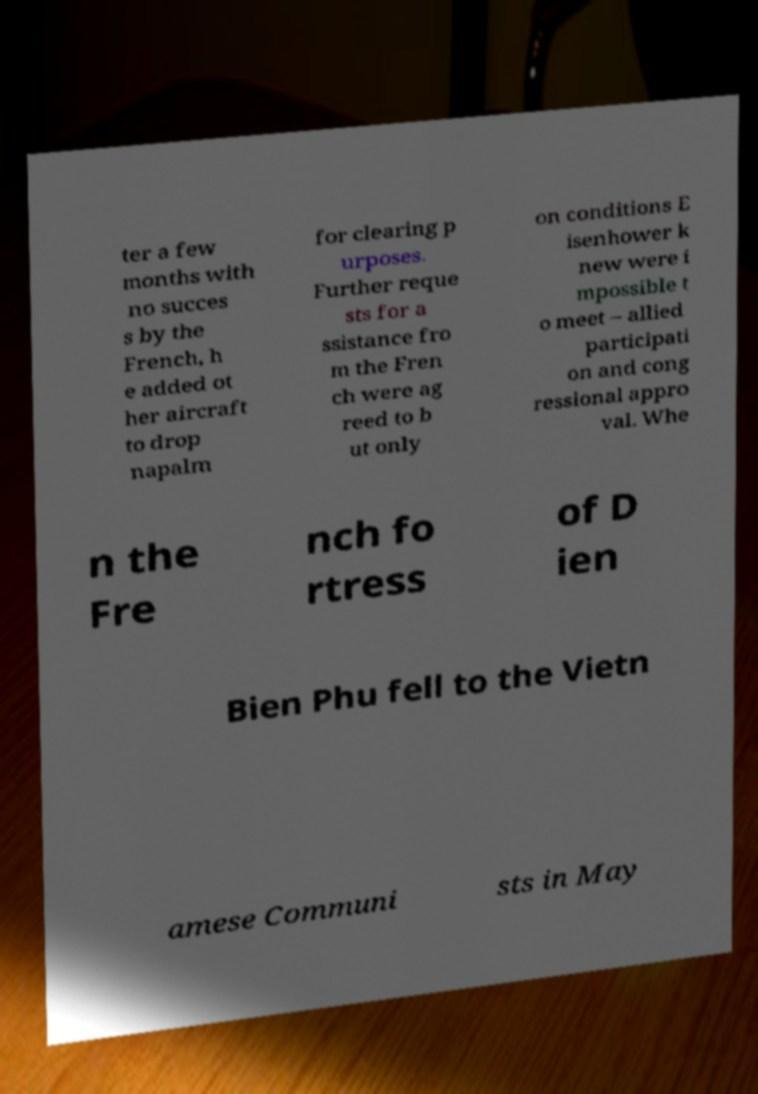For documentation purposes, I need the text within this image transcribed. Could you provide that? ter a few months with no succes s by the French, h e added ot her aircraft to drop napalm for clearing p urposes. Further reque sts for a ssistance fro m the Fren ch were ag reed to b ut only on conditions E isenhower k new were i mpossible t o meet – allied participati on and cong ressional appro val. Whe n the Fre nch fo rtress of D ien Bien Phu fell to the Vietn amese Communi sts in May 